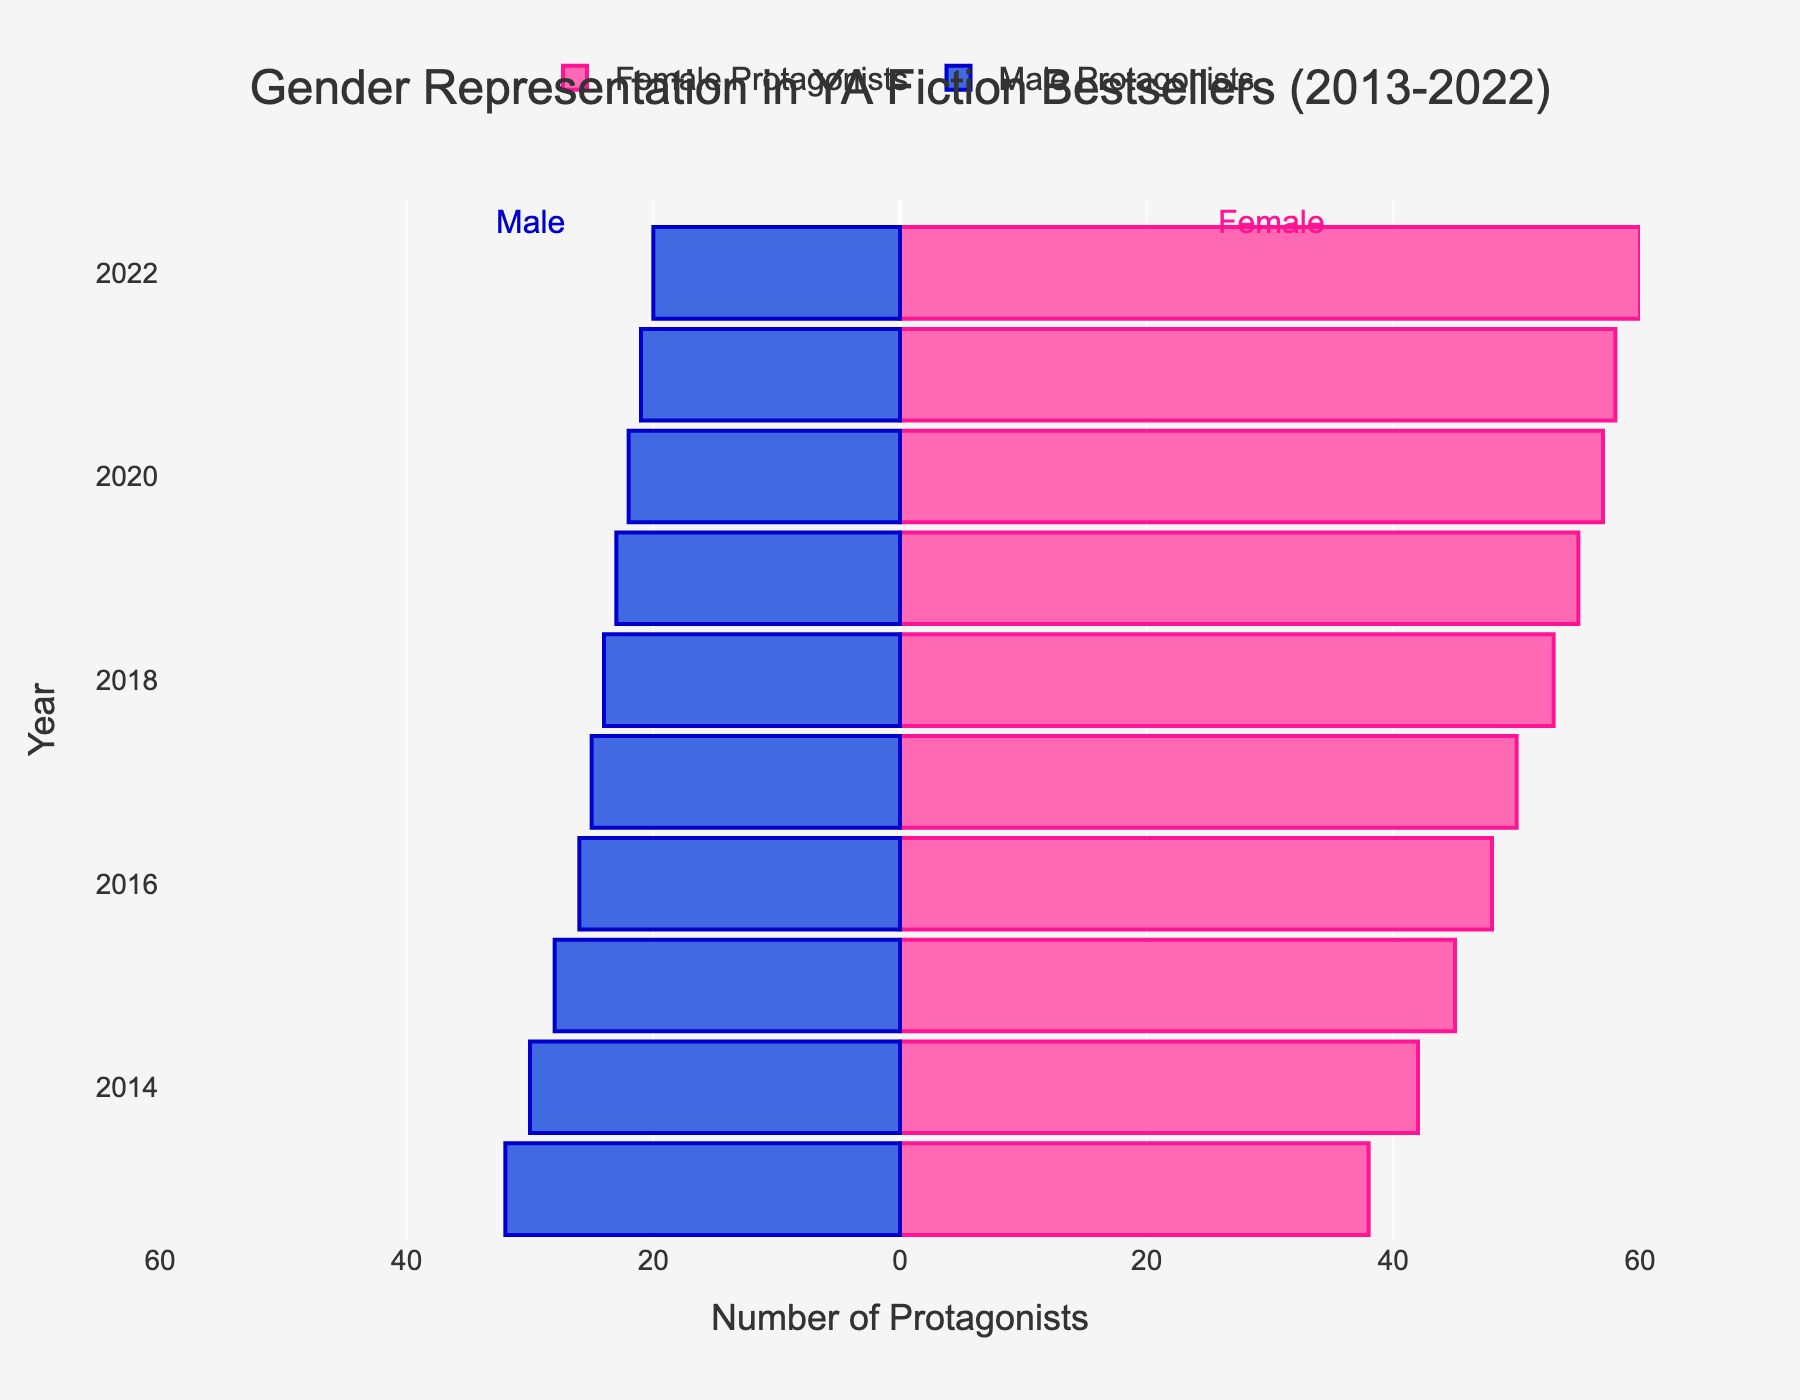Which gender has more protagonists in 2022? In 2022, the bar for female protagonists extends further to the right compared to the bar for male protagonists, which extends to the left.
Answer: Female How many total male protagonists are there in 2019? For 2019, the number of male protagonists is visually indicated on the plot by the length of the bar extending to the left. The default bar length suggests there are 23 male protagonists.
Answer: 23 What is the overall trend for female protagonists from 2013 to 2022? By observing the length of the bars for female protagonists, it can be seen that they steadily increase each year from 38 in 2013 to 60 in 2022.
Answer: Increasing trend How many more female protagonists were there compared to male protagonists in 2016? In 2016, there were 48 female protagonists and 26 male protagonists. The difference is 48 - 26 = 22.
Answer: 22 Which year had the highest number of combined protagonists and what is that number? To find this, sum the absolute values of both male and female protagonists for each year. The year 2022 has the highest sum: 60 (female) + 20 (male) = 80.
Answer: 2022, 80 Between which years did female protagonists increase the most? Comparing year-over-year increases, the largest increase is from 2020 to 2021, where the number of female protagonists goes from 57 to 58.
Answer: 2020 to 2021 How did the number of male protagonists change from 2013 to 2022? The number of male protagonists steadily decreased each year from 32 in 2013 to 20 in 2022.
Answer: Decreasing trend Which year had the smallest gap between female and male protagonists? Calculate the absolute difference for each year. The smallest gap is in 2013, where the difference is 38 (female) - 32 (male) = 6.
Answer: 2013 What is the average number of female protagonists over the decade? Sum all the values for female protagonists and divide by the number of years: (38+42+45+48+50+53+55+57+58+60)/10 = 50.6.
Answer: 50.6 